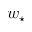Convert formula to latex. <formula><loc_0><loc_0><loc_500><loc_500>w _ { ^ { * } }</formula> 